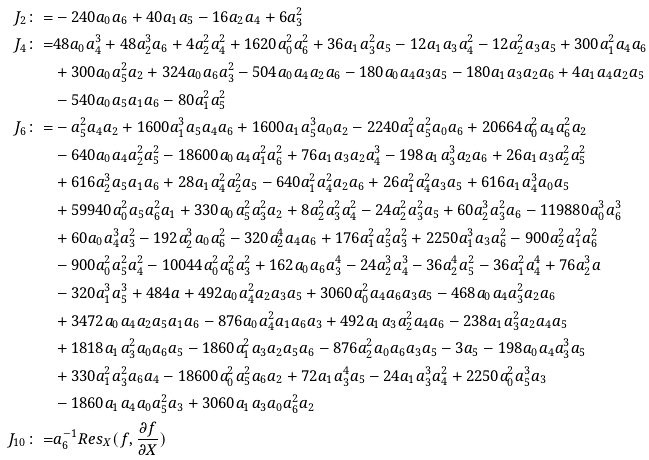Convert formula to latex. <formula><loc_0><loc_0><loc_500><loc_500>J _ { 2 } \colon = & - 2 4 0 a _ { 0 } a _ { 6 } + 4 0 a _ { 1 } a _ { 5 } - 1 6 a _ { 2 } a _ { 4 } + 6 a _ { 3 } ^ { 2 } \\ J _ { 4 } \colon = & 4 8 a _ { 0 } a _ { 4 } ^ { 3 } + 4 8 a _ { 2 } ^ { 3 } a _ { 6 } + 4 a _ { 2 } ^ { 2 } a _ { 4 } ^ { 2 } + 1 6 2 0 a _ { 0 } ^ { 2 } a _ { 6 } ^ { 2 } + 3 6 a _ { 1 } a _ { 3 } ^ { 2 } a _ { 5 } - 1 2 a _ { 1 } a _ { 3 } a _ { 4 } ^ { 2 } - 1 2 a _ { 2 } ^ { 2 } a _ { 3 } a _ { 5 } + 3 0 0 a _ { 1 } ^ { 2 } a _ { 4 } a _ { 6 } \\ & + 3 0 0 a _ { 0 } a _ { 5 } ^ { 2 } a _ { 2 } + 3 2 4 a _ { 0 } a _ { 6 } a _ { 3 } ^ { 2 } - 5 0 4 a _ { 0 } a _ { 4 } a _ { 2 } a _ { 6 } - 1 8 0 a _ { 0 } a _ { 4 } a _ { 3 } a _ { 5 } - 1 8 0 a _ { 1 } a _ { 3 } a _ { 2 } a _ { 6 } + 4 a _ { 1 } a _ { 4 } a _ { 2 } a _ { 5 } \\ & - 5 4 0 a _ { 0 } a _ { 5 } a _ { 1 } a _ { 6 } - 8 0 a _ { 1 } ^ { 2 } a _ { 5 } ^ { 2 } \\ J _ { 6 } \colon = & - a _ { 5 } ^ { 2 } a _ { 4 } a _ { 2 } + 1 6 0 0 a _ { 1 } ^ { 3 } a _ { 5 } a _ { 4 } a _ { 6 } + 1 6 0 0 a _ { 1 } a _ { 5 } ^ { 3 } a _ { 0 } a _ { 2 } - 2 2 4 0 a _ { 1 } ^ { 2 } a _ { 5 } ^ { 2 } a _ { 0 } a _ { 6 } + 2 0 6 6 4 a _ { 0 } ^ { 2 } a _ { 4 } a _ { 6 } ^ { 2 } a _ { 2 } \\ & - 6 4 0 a _ { 0 } a _ { 4 } a _ { 2 } ^ { 2 } a _ { 5 } ^ { 2 } - 1 8 6 0 0 a _ { 0 } a _ { 4 } a _ { 1 } ^ { 2 } a _ { 6 } ^ { 2 } + 7 6 a _ { 1 } a _ { 3 } a _ { 2 } a _ { 4 } ^ { 3 } - 1 9 8 a _ { 1 } a _ { 3 } ^ { 3 } a _ { 2 } a _ { 6 } + 2 6 a _ { 1 } a _ { 3 } a _ { 2 } ^ { 2 } a _ { 5 } ^ { 2 } \\ & + 6 1 6 a _ { 2 } ^ { 3 } a _ { 5 } a _ { 1 } a _ { 6 } + 2 8 a _ { 1 } a _ { 4 } ^ { 2 } a _ { 2 } ^ { 2 } a _ { 5 } - 6 4 0 a _ { 1 } ^ { 2 } a _ { 4 } ^ { 2 } a _ { 2 } a _ { 6 } + 2 6 a _ { 1 } ^ { 2 } a _ { 4 } ^ { 2 } a _ { 3 } a _ { 5 } + 6 1 6 a _ { 1 } a _ { 4 } ^ { 3 } a _ { 0 } a _ { 5 } \\ & + 5 9 9 4 0 a _ { 0 } ^ { 2 } a _ { 5 } a _ { 6 } ^ { 2 } a _ { 1 } + 3 3 0 a _ { 0 } a _ { 5 } ^ { 2 } a _ { 3 } ^ { 2 } a _ { 2 } + 8 a _ { 2 } ^ { 2 } a _ { 3 } ^ { 2 } a _ { 4 } ^ { 2 } - 2 4 a _ { 2 } ^ { 2 } a _ { 3 } ^ { 2 } a _ { 5 } + 6 0 a _ { 2 } ^ { 3 } a _ { 3 } ^ { 2 } a _ { 6 } - 1 1 9 8 8 0 a _ { 0 } ^ { 3 } a _ { 6 } ^ { 3 } \\ & + 6 0 a _ { 0 } a _ { 4 } ^ { 3 } a _ { 3 } ^ { 2 } - 1 9 2 a _ { 2 } ^ { 3 } a _ { 0 } a _ { 6 } ^ { 2 } - 3 2 0 a _ { 2 } ^ { 4 } a _ { 4 } a _ { 6 } + 1 7 6 a _ { 1 } ^ { 2 } a _ { 5 } ^ { 2 } a _ { 3 } ^ { 2 } + 2 2 5 0 a _ { 1 } ^ { 3 } a _ { 3 } a _ { 6 } ^ { 2 } - 9 0 0 a _ { 2 } ^ { 2 } a _ { 1 } ^ { 2 } a _ { 6 } ^ { 2 } \\ & - 9 0 0 a _ { 0 } ^ { 2 } a _ { 5 } ^ { 2 } a _ { 4 } ^ { 2 } - 1 0 0 4 4 a _ { 0 } ^ { 2 } a _ { 6 } ^ { 2 } a _ { 3 } ^ { 2 } + 1 6 2 a _ { 0 } a _ { 6 } a _ { 3 } ^ { 4 } - 2 4 a _ { 2 } ^ { 3 } a _ { 4 } ^ { 3 } - 3 6 a _ { 2 } ^ { 4 } a _ { 5 } ^ { 2 } - 3 6 a _ { 1 } ^ { 2 } a _ { 4 } ^ { 4 } + 7 6 a _ { 2 } ^ { 3 } a \\ & - 3 2 0 a _ { 1 } ^ { 3 } a _ { 5 } ^ { 3 } + 4 8 4 a + 4 9 2 a _ { 0 } a _ { 4 } ^ { 2 } a _ { 2 } a _ { 3 } a _ { 5 } + 3 0 6 0 a _ { 0 } ^ { 2 } a _ { 4 } a _ { 6 } a _ { 3 } a _ { 5 } - 4 6 8 a _ { 0 } a _ { 4 } a _ { 3 } ^ { 2 } a _ { 2 } a _ { 6 } \\ & + 3 4 7 2 a _ { 0 } a _ { 4 } a _ { 2 } a _ { 5 } a _ { 1 } a _ { 6 } - 8 7 6 a _ { 0 } a _ { 4 } ^ { 2 } a _ { 1 } a _ { 6 } a _ { 3 } + 4 9 2 a _ { 1 } a _ { 3 } a _ { 2 } ^ { 2 } a _ { 4 } a _ { 6 } - 2 3 8 a _ { 1 } a _ { 3 } ^ { 2 } a _ { 2 } a _ { 4 } a _ { 5 } \\ & + 1 8 1 8 a _ { 1 } a _ { 3 } ^ { 2 } a _ { 0 } a _ { 6 } a _ { 5 } - 1 8 6 0 a _ { 1 } ^ { 2 } a _ { 3 } a _ { 2 } a _ { 5 } a _ { 6 } - 8 7 6 a _ { 2 } ^ { 2 } a _ { 0 } a _ { 6 } a _ { 3 } a _ { 5 } - 3 a _ { 5 } - 1 9 8 a _ { 0 } a _ { 4 } a _ { 3 } ^ { 3 } a _ { 5 } \\ & + 3 3 0 a _ { 1 } ^ { 2 } a _ { 3 } ^ { 2 } a _ { 6 } a _ { 4 } - 1 8 6 0 0 a _ { 0 } ^ { 2 } a _ { 5 } ^ { 2 } a _ { 6 } a _ { 2 } + 7 2 a _ { 1 } a _ { 3 } ^ { 4 } a _ { 5 } - 2 4 a _ { 1 } a _ { 3 } ^ { 3 } a _ { 4 } ^ { 2 } + 2 2 5 0 a _ { 0 } ^ { 2 } a _ { 5 } ^ { 3 } a _ { 3 } \\ & - 1 8 6 0 a _ { 1 } a _ { 4 } a _ { 0 } a _ { 5 } ^ { 2 } a _ { 3 } + 3 0 6 0 a _ { 1 } a _ { 3 } a _ { 0 } a _ { 6 } ^ { 2 } a _ { 2 } \\ J _ { 1 0 } \colon = & a _ { 6 } ^ { - 1 } R e s _ { X } ( f , \frac { \partial f } { \partial X } ) \\</formula> 